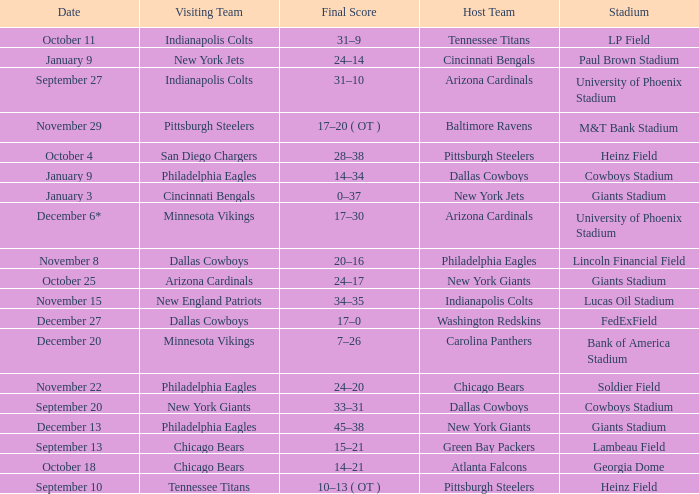Tell me the final score for january 9 for cincinnati bengals 24–14. Could you help me parse every detail presented in this table? {'header': ['Date', 'Visiting Team', 'Final Score', 'Host Team', 'Stadium'], 'rows': [['October 11', 'Indianapolis Colts', '31–9', 'Tennessee Titans', 'LP Field'], ['January 9', 'New York Jets', '24–14', 'Cincinnati Bengals', 'Paul Brown Stadium'], ['September 27', 'Indianapolis Colts', '31–10', 'Arizona Cardinals', 'University of Phoenix Stadium'], ['November 29', 'Pittsburgh Steelers', '17–20 ( OT )', 'Baltimore Ravens', 'M&T Bank Stadium'], ['October 4', 'San Diego Chargers', '28–38', 'Pittsburgh Steelers', 'Heinz Field'], ['January 9', 'Philadelphia Eagles', '14–34', 'Dallas Cowboys', 'Cowboys Stadium'], ['January 3', 'Cincinnati Bengals', '0–37', 'New York Jets', 'Giants Stadium'], ['December 6*', 'Minnesota Vikings', '17–30', 'Arizona Cardinals', 'University of Phoenix Stadium'], ['November 8', 'Dallas Cowboys', '20–16', 'Philadelphia Eagles', 'Lincoln Financial Field'], ['October 25', 'Arizona Cardinals', '24–17', 'New York Giants', 'Giants Stadium'], ['November 15', 'New England Patriots', '34–35', 'Indianapolis Colts', 'Lucas Oil Stadium'], ['December 27', 'Dallas Cowboys', '17–0', 'Washington Redskins', 'FedExField'], ['December 20', 'Minnesota Vikings', '7–26', 'Carolina Panthers', 'Bank of America Stadium'], ['November 22', 'Philadelphia Eagles', '24–20', 'Chicago Bears', 'Soldier Field'], ['September 20', 'New York Giants', '33–31', 'Dallas Cowboys', 'Cowboys Stadium'], ['December 13', 'Philadelphia Eagles', '45–38', 'New York Giants', 'Giants Stadium'], ['September 13', 'Chicago Bears', '15–21', 'Green Bay Packers', 'Lambeau Field'], ['October 18', 'Chicago Bears', '14–21', 'Atlanta Falcons', 'Georgia Dome'], ['September 10', 'Tennessee Titans', '10–13 ( OT )', 'Pittsburgh Steelers', 'Heinz Field']]} 